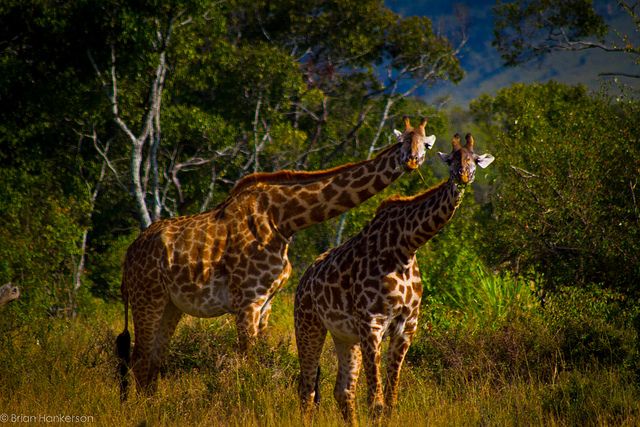<image>Which giraffe is facing a different direction? I don't know which giraffe is facing a different direction. It might be neither. How much do these animal weight? It is unanswerable how much these animals weigh. Which giraffe is facing a different direction? I don't know which giraffe is facing a different direction. It seems that neither of the giraffes are facing a different direction. How much do these animal weight? I am not sure how much these animals weight. It can be anywhere between 500 and 7000 pounds. 